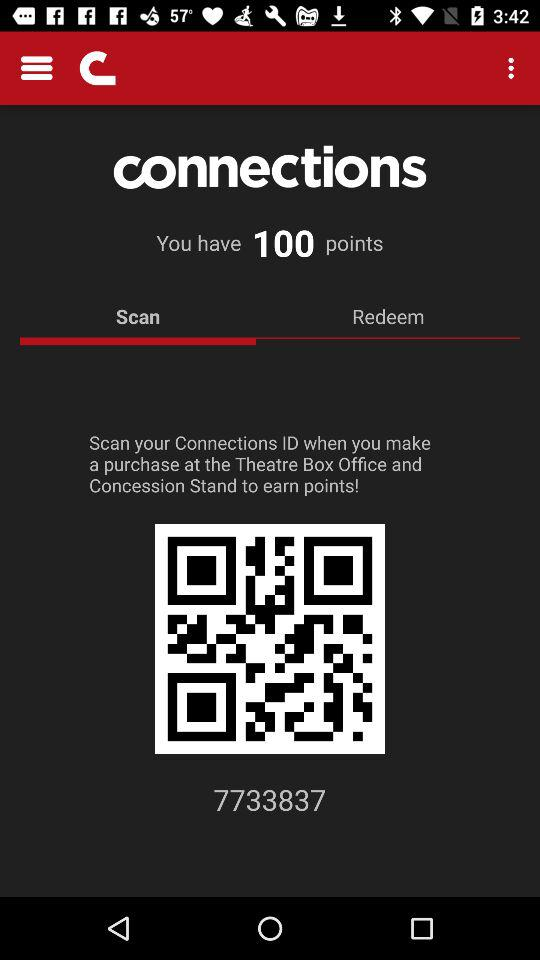What's the total number of the points? The total points are 100. 